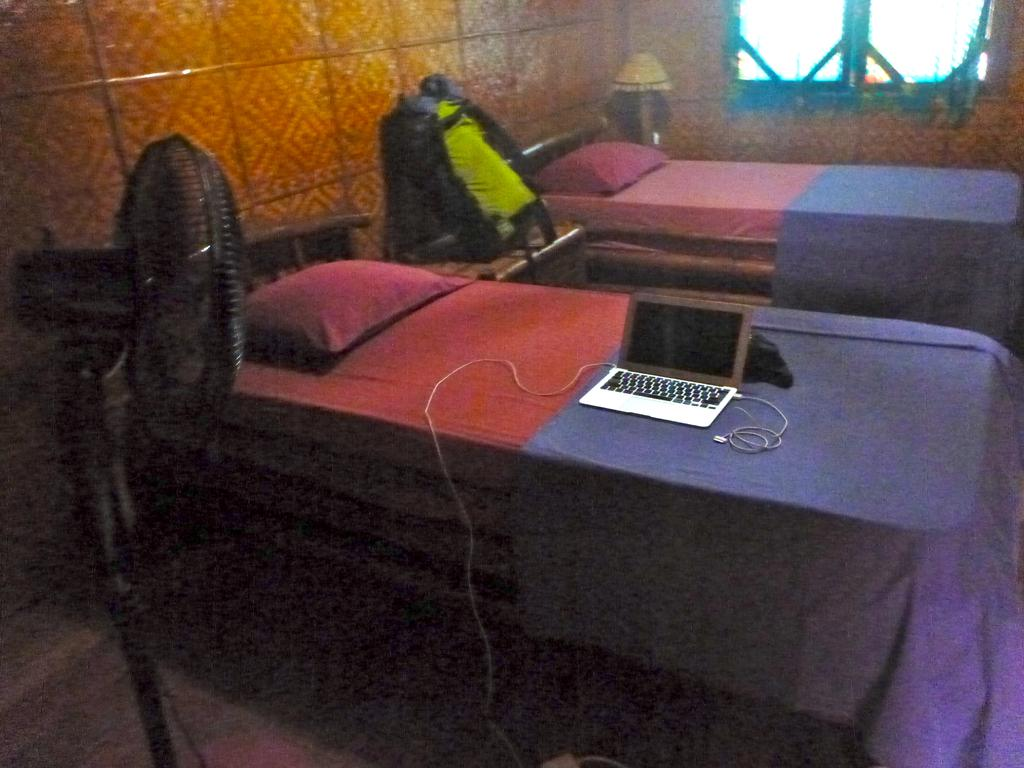What is the main object in the center of the image? There is a laptop in the center of the image. Where is the laptop placed? The laptop is placed on a bed. What can be seen in the background of the image? There is a window, a wall, and a light in the background of the image. What is the purpose of the fan in the image? The fan on the left side of the image is likely used for cooling or ventilation. How many marbles are being used as a decoration on the laptop in the image? There are no marbles present on the laptop or in the image. What type of pets can be seen in the image? There are no pets visible in the image. 